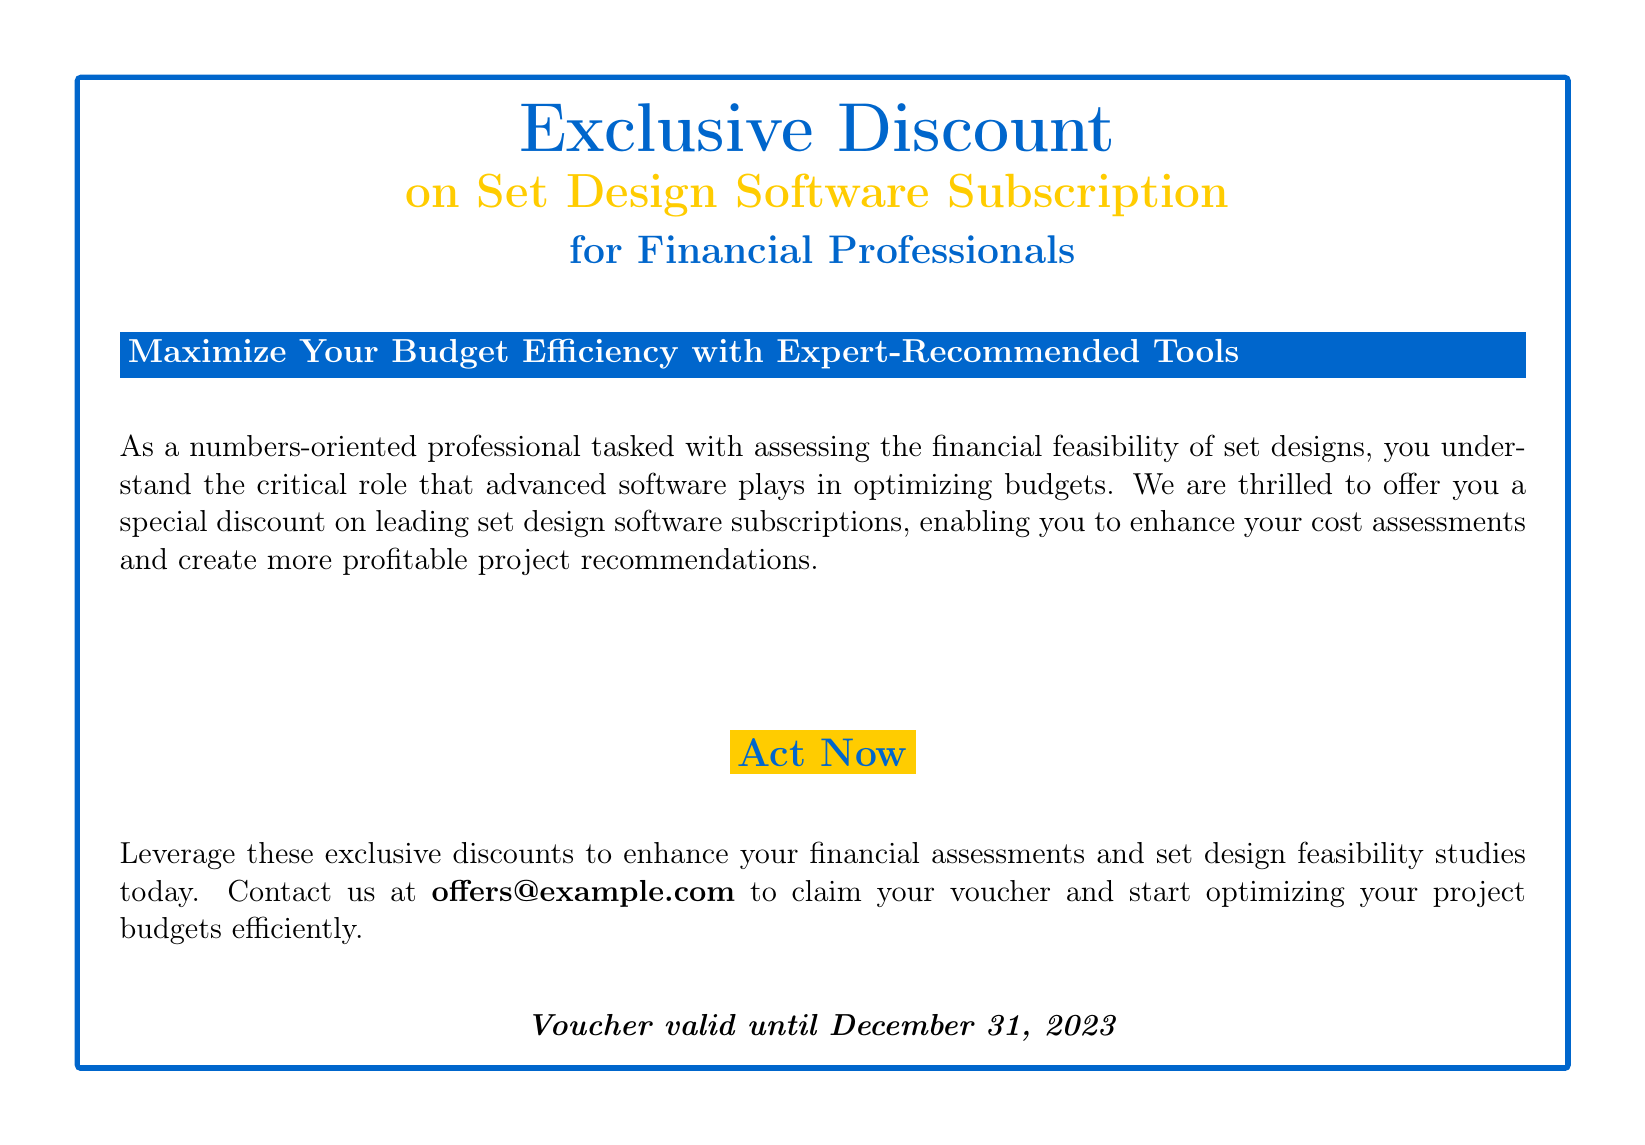What is the discount percentage for Autodesk AutoCAD? The document states that there is a 20% discount on annual subscriptions to Autodesk AutoCAD.
Answer: 20% What is the offer validity date? The document specifies that the voucher is valid until December 31, 2023.
Answer: December 31, 2023 Which software has a 15% discount? The document mentions that SketchUp Pro is available at a 15% discount for a limited time.
Answer: SketchUp Pro What support is provided with Vectorworks Designer? The document states that with each purchase of Vectorworks Designer, there is access to a dedicated support team.
Answer: Dedicated support team What is the discount for Live Home 3D? According to the document, Live Home 3D is available at a 25% discount.
Answer: 25% What kind of professionals is the voucher targeted towards? The document highlights that the offer is exclusively available to financial professionals focused on project budgeting.
Answer: Financial professionals What is the main purpose of the discount offered? The document emphasizes that the discount aims to enhance financial assessments and set design feasibility studies.
Answer: Enhance financial assessments What is the color of the main title in the document? The document uses the color blue for the main title, specifically noted as RGB(0,102,204).
Answer: Blue 